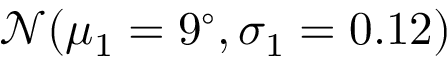<formula> <loc_0><loc_0><loc_500><loc_500>\mathcal { N } ( \mu _ { 1 } = 9 ^ { \circ } , \sigma _ { 1 } = 0 . 1 2 )</formula> 